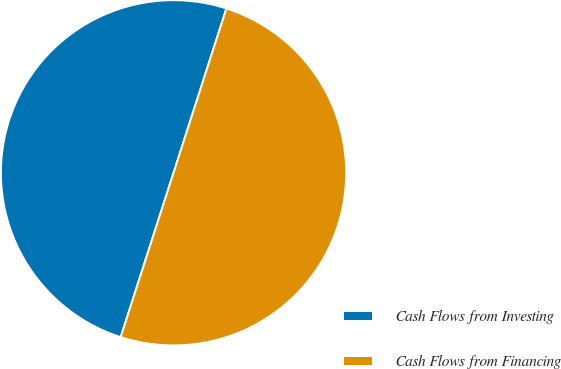<chart> <loc_0><loc_0><loc_500><loc_500><pie_chart><fcel>Cash Flows from Investing<fcel>Cash Flows from Financing<nl><fcel>50.0%<fcel>50.0%<nl></chart> 